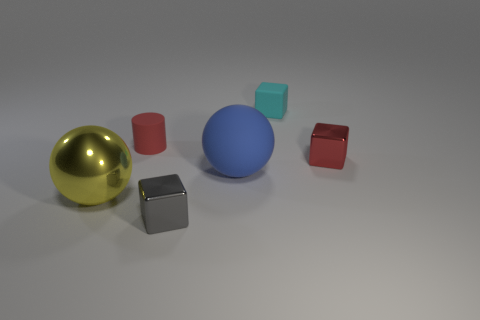What can you infer about the surface on which the objects are placed? The objects are set on a flat, smooth surface that has a subtle reflection, indicating it might be slightly glossy or polished. The light grey shade of the surface gives the scene a neutral backdrop, which allows the colors and textures of the objects to stand out. 